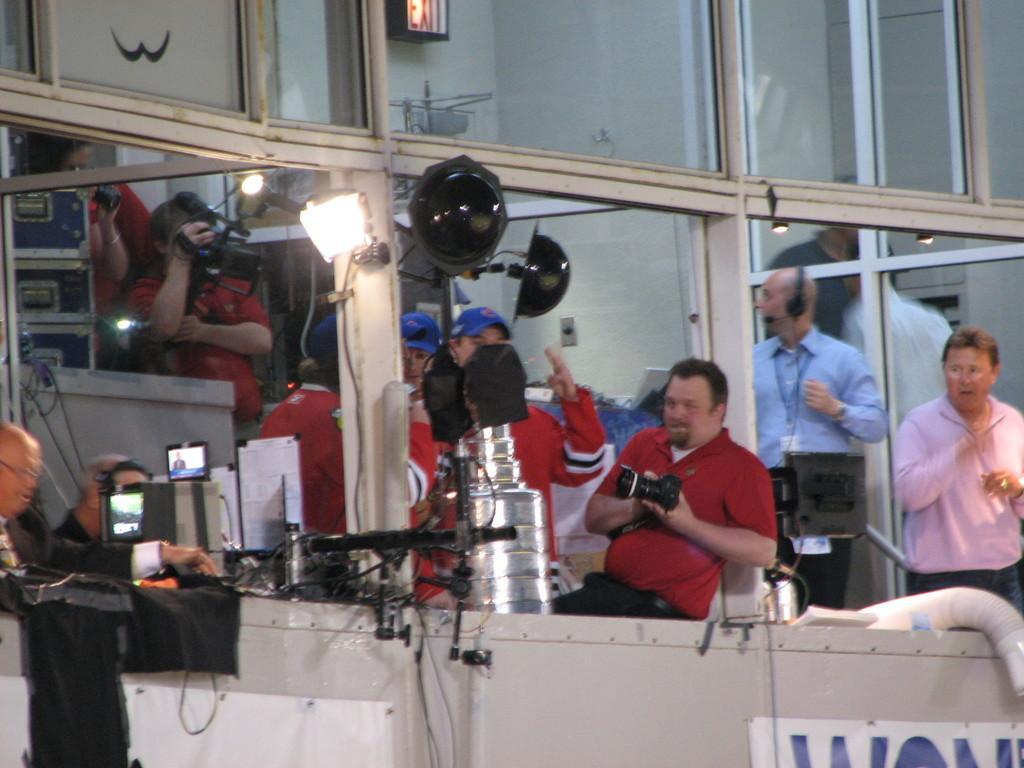Could you give a brief overview of what you see in this image? This picture shows the inner view of a room and there is one exit board, two T. V's, two paper boards, two banners. There are so many lights, some people are standing and holding some objects. So many objects are on the surface. Glass window is there, two persons are sitting near to the table, so many objects are on the table. 